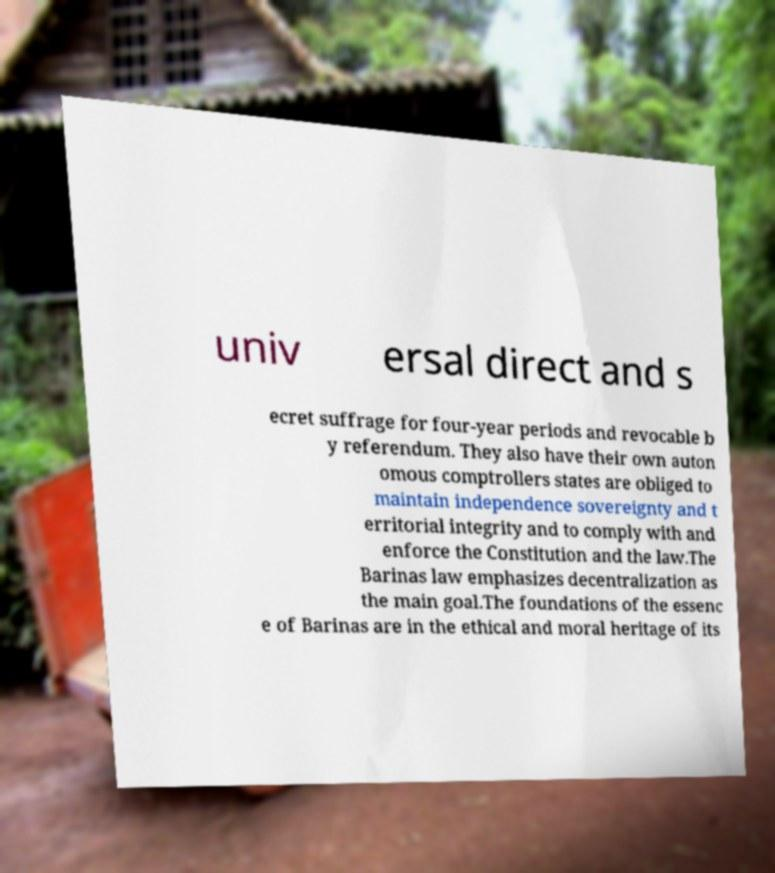I need the written content from this picture converted into text. Can you do that? univ ersal direct and s ecret suffrage for four-year periods and revocable b y referendum. They also have their own auton omous comptrollers states are obliged to maintain independence sovereignty and t erritorial integrity and to comply with and enforce the Constitution and the law.The Barinas law emphasizes decentralization as the main goal.The foundations of the essenc e of Barinas are in the ethical and moral heritage of its 